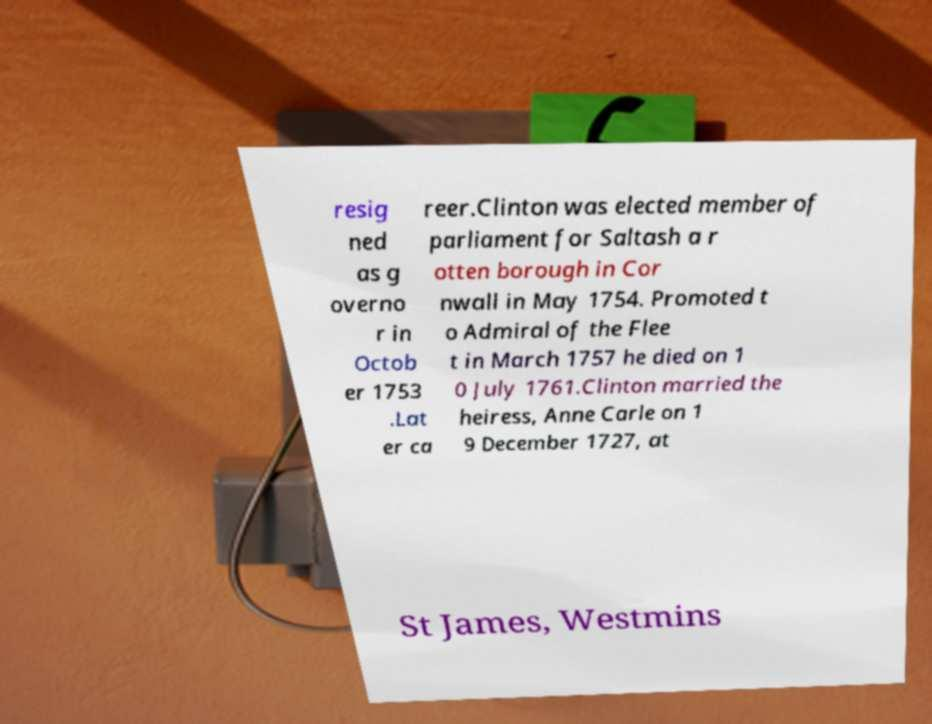There's text embedded in this image that I need extracted. Can you transcribe it verbatim? resig ned as g overno r in Octob er 1753 .Lat er ca reer.Clinton was elected member of parliament for Saltash a r otten borough in Cor nwall in May 1754. Promoted t o Admiral of the Flee t in March 1757 he died on 1 0 July 1761.Clinton married the heiress, Anne Carle on 1 9 December 1727, at St James, Westmins 